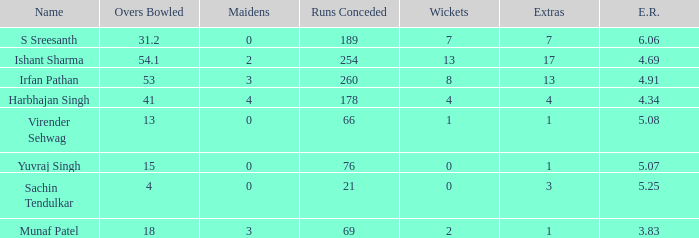What do you call the situation when 3 S Sreesanth. 